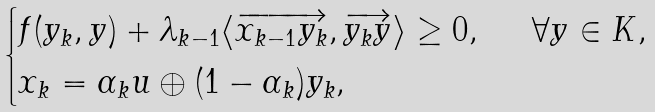Convert formula to latex. <formula><loc_0><loc_0><loc_500><loc_500>\begin{cases} f ( y _ { k } , y ) + \lambda _ { k - 1 } \langle \overrightarrow { x _ { k - 1 } y _ { k } } , \overrightarrow { y _ { k } y } \rangle \geq 0 , \quad \ \forall y \in K , \\ x _ { k } = \alpha _ { k } u \oplus ( 1 - \alpha _ { k } ) y _ { k } , \\ \end{cases}</formula> 